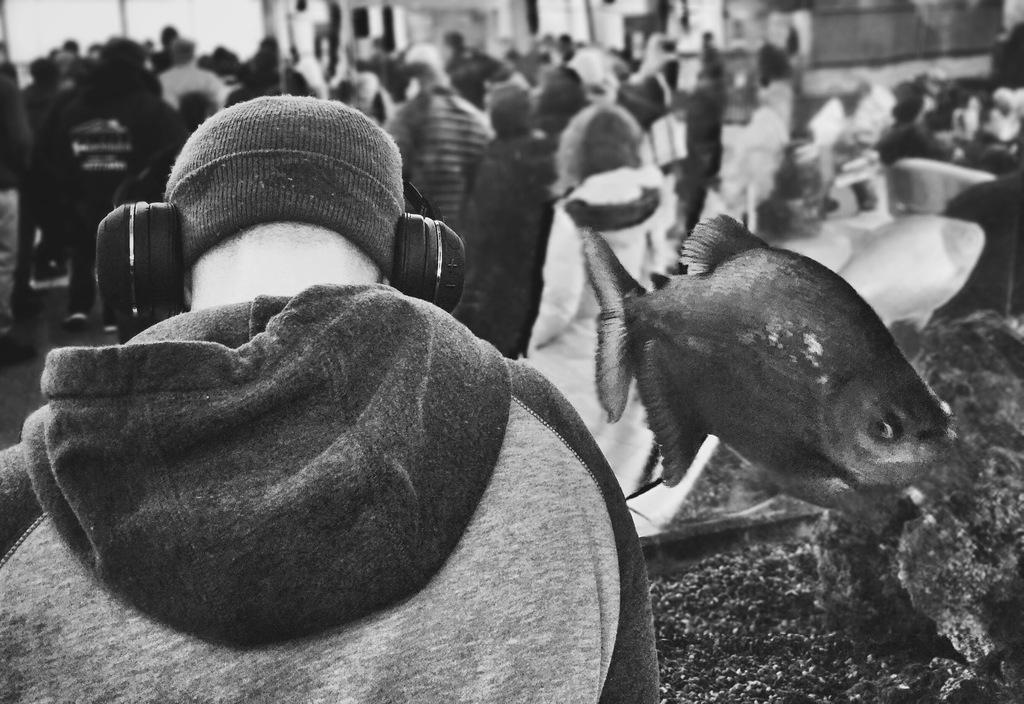What can be seen in the image regarding people? There are people standing in the image. Can you describe the man in the image? The man is standing in the image and is wearing a cap on his head. What else is the man wearing in the image? The man is wearing a headset in the image. What is present in the image that contains aquatic life? There is an aquarium in the image that contains fishes. What type of whip is the man holding in the image? There is no whip present in the image; the man is wearing a cap and a headset. Is there a rifle visible in the image? No, there is no rifle present in the image. 